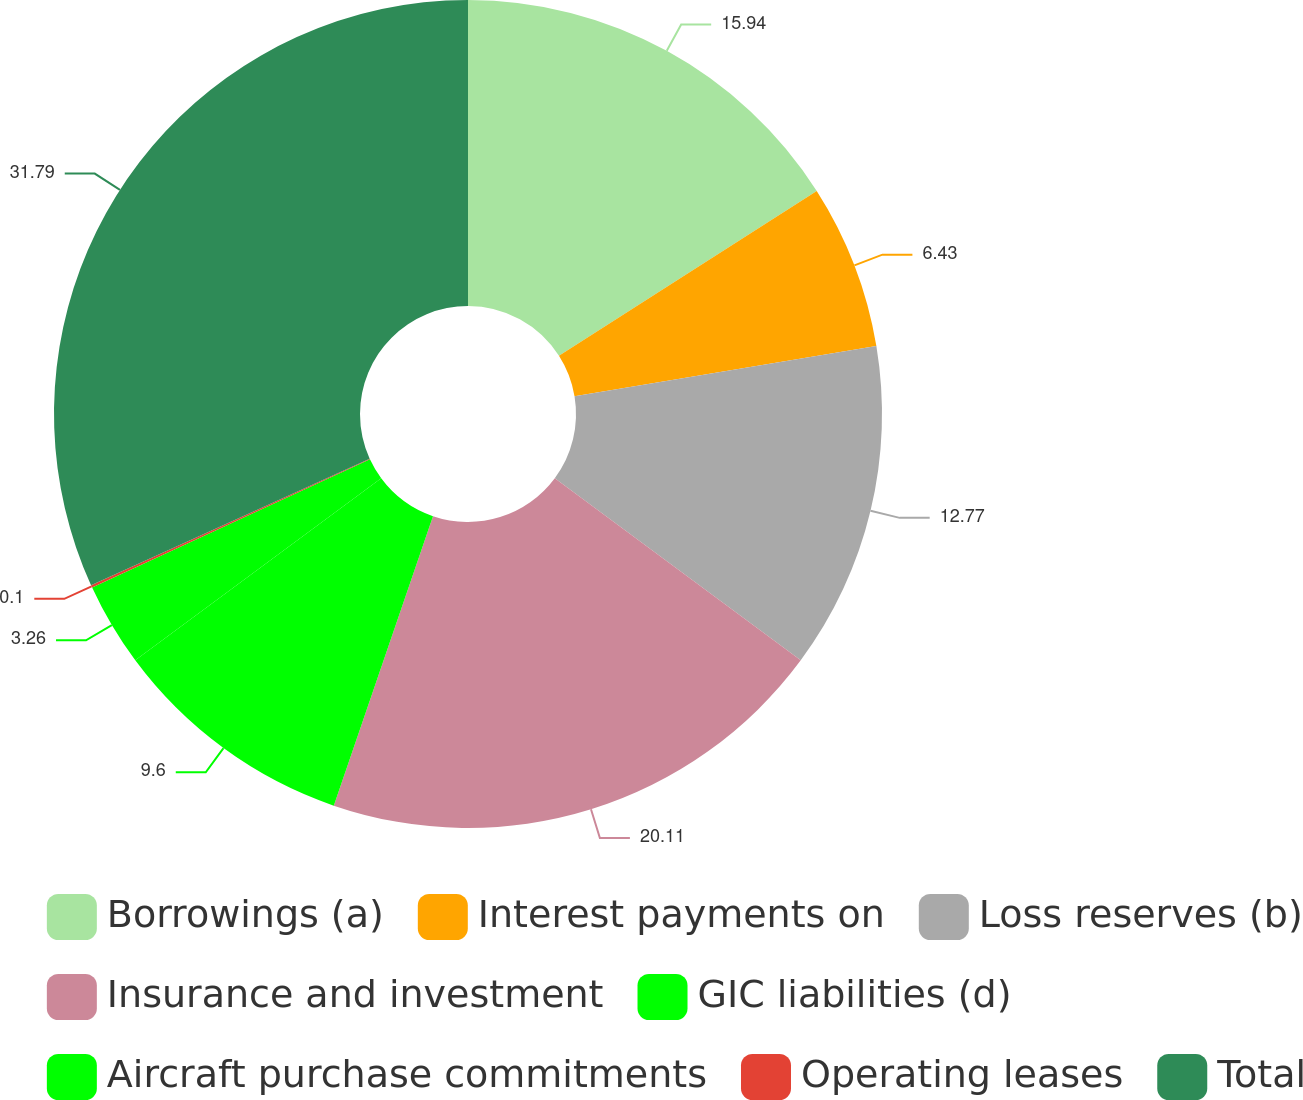<chart> <loc_0><loc_0><loc_500><loc_500><pie_chart><fcel>Borrowings (a)<fcel>Interest payments on<fcel>Loss reserves (b)<fcel>Insurance and investment<fcel>GIC liabilities (d)<fcel>Aircraft purchase commitments<fcel>Operating leases<fcel>Total<nl><fcel>15.94%<fcel>6.43%<fcel>12.77%<fcel>20.11%<fcel>9.6%<fcel>3.26%<fcel>0.1%<fcel>31.78%<nl></chart> 